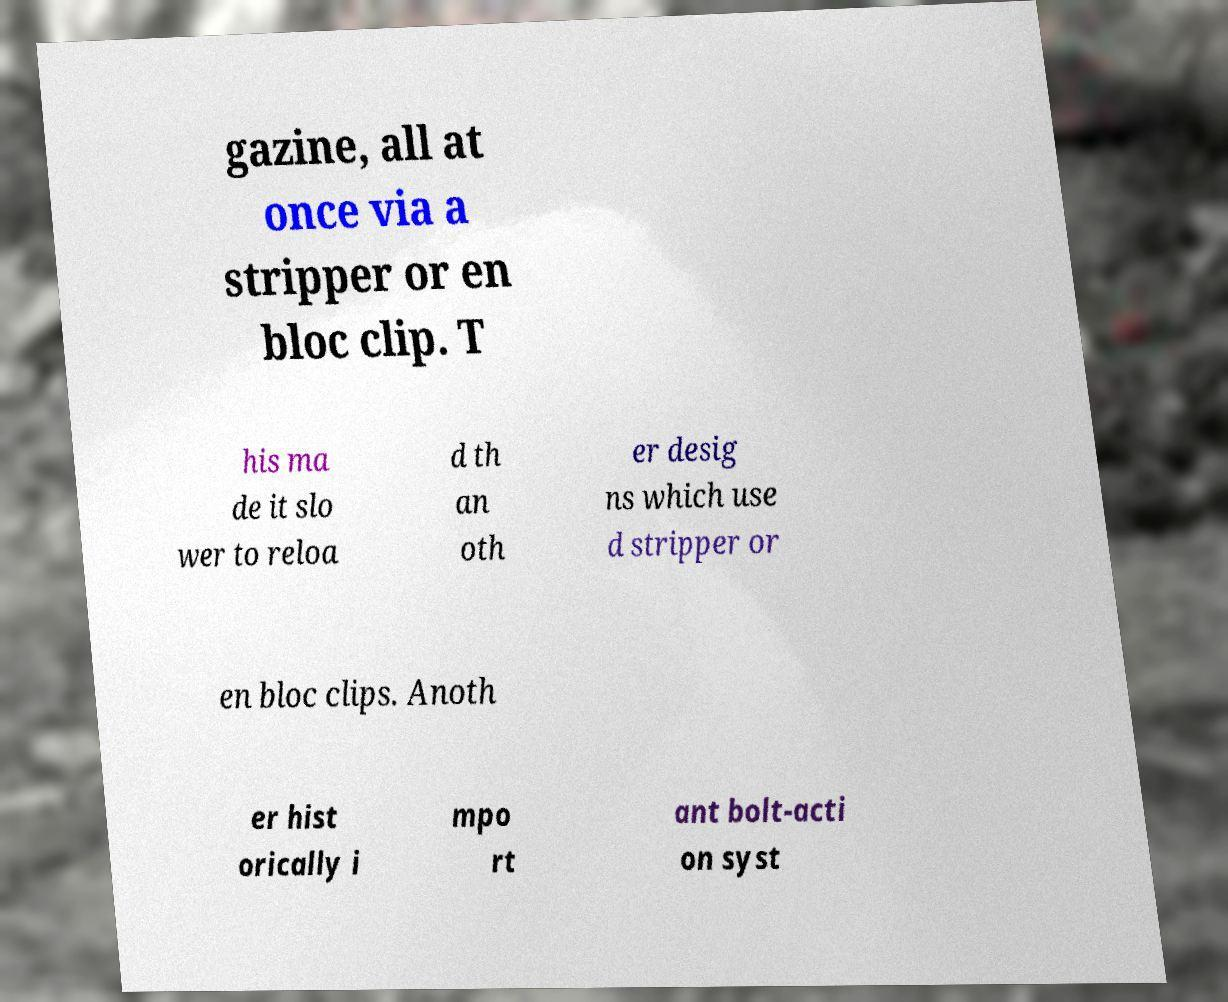For documentation purposes, I need the text within this image transcribed. Could you provide that? gazine, all at once via a stripper or en bloc clip. T his ma de it slo wer to reloa d th an oth er desig ns which use d stripper or en bloc clips. Anoth er hist orically i mpo rt ant bolt-acti on syst 